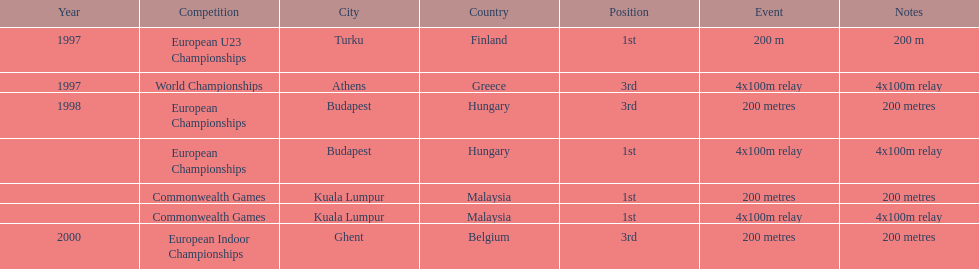How many 4x 100m relays were run? 3. 